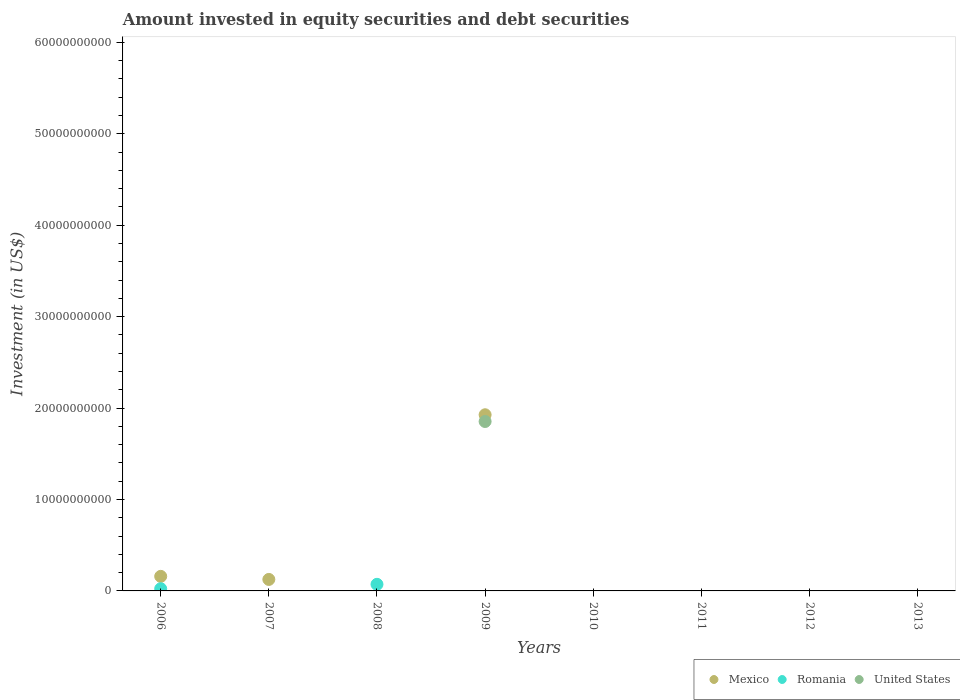Is the number of dotlines equal to the number of legend labels?
Make the answer very short. No. What is the amount invested in equity securities and debt securities in Mexico in 2009?
Ensure brevity in your answer.  1.93e+1. Across all years, what is the maximum amount invested in equity securities and debt securities in United States?
Offer a terse response. 1.85e+1. What is the total amount invested in equity securities and debt securities in United States in the graph?
Make the answer very short. 1.85e+1. What is the difference between the amount invested in equity securities and debt securities in Mexico in 2006 and that in 2007?
Your answer should be compact. 3.35e+08. What is the difference between the amount invested in equity securities and debt securities in Romania in 2013 and the amount invested in equity securities and debt securities in United States in 2007?
Give a very brief answer. 0. What is the average amount invested in equity securities and debt securities in United States per year?
Your answer should be very brief. 2.32e+09. In the year 2009, what is the difference between the amount invested in equity securities and debt securities in United States and amount invested in equity securities and debt securities in Mexico?
Make the answer very short. -7.36e+08. What is the ratio of the amount invested in equity securities and debt securities in Mexico in 2006 to that in 2007?
Provide a succinct answer. 1.27. What is the difference between the highest and the second highest amount invested in equity securities and debt securities in Mexico?
Give a very brief answer. 1.77e+1. What is the difference between the highest and the lowest amount invested in equity securities and debt securities in United States?
Ensure brevity in your answer.  1.85e+1. In how many years, is the amount invested in equity securities and debt securities in United States greater than the average amount invested in equity securities and debt securities in United States taken over all years?
Offer a terse response. 1. Is it the case that in every year, the sum of the amount invested in equity securities and debt securities in United States and amount invested in equity securities and debt securities in Romania  is greater than the amount invested in equity securities and debt securities in Mexico?
Your answer should be compact. No. Does the amount invested in equity securities and debt securities in Mexico monotonically increase over the years?
Ensure brevity in your answer.  No. Is the amount invested in equity securities and debt securities in United States strictly less than the amount invested in equity securities and debt securities in Romania over the years?
Make the answer very short. No. How many years are there in the graph?
Your answer should be compact. 8. Are the values on the major ticks of Y-axis written in scientific E-notation?
Ensure brevity in your answer.  No. Where does the legend appear in the graph?
Your answer should be compact. Bottom right. How many legend labels are there?
Provide a succinct answer. 3. How are the legend labels stacked?
Offer a terse response. Horizontal. What is the title of the graph?
Offer a terse response. Amount invested in equity securities and debt securities. Does "Middle East & North Africa (all income levels)" appear as one of the legend labels in the graph?
Offer a very short reply. No. What is the label or title of the Y-axis?
Offer a very short reply. Investment (in US$). What is the Investment (in US$) in Mexico in 2006?
Keep it short and to the point. 1.59e+09. What is the Investment (in US$) in Romania in 2006?
Provide a succinct answer. 2.39e+08. What is the Investment (in US$) in Mexico in 2007?
Offer a very short reply. 1.26e+09. What is the Investment (in US$) of Romania in 2007?
Your response must be concise. 0. What is the Investment (in US$) of United States in 2007?
Offer a terse response. 0. What is the Investment (in US$) of Mexico in 2008?
Your answer should be compact. 0. What is the Investment (in US$) in Romania in 2008?
Your answer should be very brief. 7.22e+08. What is the Investment (in US$) in Mexico in 2009?
Offer a very short reply. 1.93e+1. What is the Investment (in US$) in Romania in 2009?
Keep it short and to the point. 0. What is the Investment (in US$) in United States in 2009?
Your answer should be very brief. 1.85e+1. What is the Investment (in US$) in Mexico in 2010?
Give a very brief answer. 0. What is the Investment (in US$) of Romania in 2010?
Give a very brief answer. 0. What is the Investment (in US$) of Mexico in 2011?
Your answer should be very brief. 0. What is the Investment (in US$) of Romania in 2011?
Your answer should be compact. 0. What is the Investment (in US$) of Romania in 2012?
Your response must be concise. 0. What is the Investment (in US$) in Romania in 2013?
Provide a short and direct response. 0. What is the Investment (in US$) of United States in 2013?
Your answer should be compact. 0. Across all years, what is the maximum Investment (in US$) of Mexico?
Your answer should be compact. 1.93e+1. Across all years, what is the maximum Investment (in US$) in Romania?
Give a very brief answer. 7.22e+08. Across all years, what is the maximum Investment (in US$) in United States?
Provide a succinct answer. 1.85e+1. What is the total Investment (in US$) of Mexico in the graph?
Give a very brief answer. 2.21e+1. What is the total Investment (in US$) in Romania in the graph?
Give a very brief answer. 9.61e+08. What is the total Investment (in US$) in United States in the graph?
Give a very brief answer. 1.85e+1. What is the difference between the Investment (in US$) of Mexico in 2006 and that in 2007?
Keep it short and to the point. 3.35e+08. What is the difference between the Investment (in US$) of Romania in 2006 and that in 2008?
Provide a short and direct response. -4.83e+08. What is the difference between the Investment (in US$) of Mexico in 2006 and that in 2009?
Make the answer very short. -1.77e+1. What is the difference between the Investment (in US$) of Mexico in 2007 and that in 2009?
Your answer should be compact. -1.80e+1. What is the difference between the Investment (in US$) of Mexico in 2006 and the Investment (in US$) of Romania in 2008?
Your answer should be very brief. 8.70e+08. What is the difference between the Investment (in US$) in Mexico in 2006 and the Investment (in US$) in United States in 2009?
Your response must be concise. -1.69e+1. What is the difference between the Investment (in US$) in Romania in 2006 and the Investment (in US$) in United States in 2009?
Provide a short and direct response. -1.83e+1. What is the difference between the Investment (in US$) of Mexico in 2007 and the Investment (in US$) of Romania in 2008?
Your response must be concise. 5.35e+08. What is the difference between the Investment (in US$) of Mexico in 2007 and the Investment (in US$) of United States in 2009?
Your response must be concise. -1.73e+1. What is the difference between the Investment (in US$) of Romania in 2008 and the Investment (in US$) of United States in 2009?
Make the answer very short. -1.78e+1. What is the average Investment (in US$) of Mexico per year?
Give a very brief answer. 2.76e+09. What is the average Investment (in US$) in Romania per year?
Provide a succinct answer. 1.20e+08. What is the average Investment (in US$) in United States per year?
Give a very brief answer. 2.32e+09. In the year 2006, what is the difference between the Investment (in US$) of Mexico and Investment (in US$) of Romania?
Give a very brief answer. 1.35e+09. In the year 2009, what is the difference between the Investment (in US$) of Mexico and Investment (in US$) of United States?
Make the answer very short. 7.36e+08. What is the ratio of the Investment (in US$) in Mexico in 2006 to that in 2007?
Keep it short and to the point. 1.27. What is the ratio of the Investment (in US$) in Romania in 2006 to that in 2008?
Ensure brevity in your answer.  0.33. What is the ratio of the Investment (in US$) in Mexico in 2006 to that in 2009?
Make the answer very short. 0.08. What is the ratio of the Investment (in US$) of Mexico in 2007 to that in 2009?
Provide a succinct answer. 0.07. What is the difference between the highest and the second highest Investment (in US$) of Mexico?
Provide a short and direct response. 1.77e+1. What is the difference between the highest and the lowest Investment (in US$) of Mexico?
Offer a terse response. 1.93e+1. What is the difference between the highest and the lowest Investment (in US$) in Romania?
Offer a terse response. 7.22e+08. What is the difference between the highest and the lowest Investment (in US$) of United States?
Your answer should be very brief. 1.85e+1. 